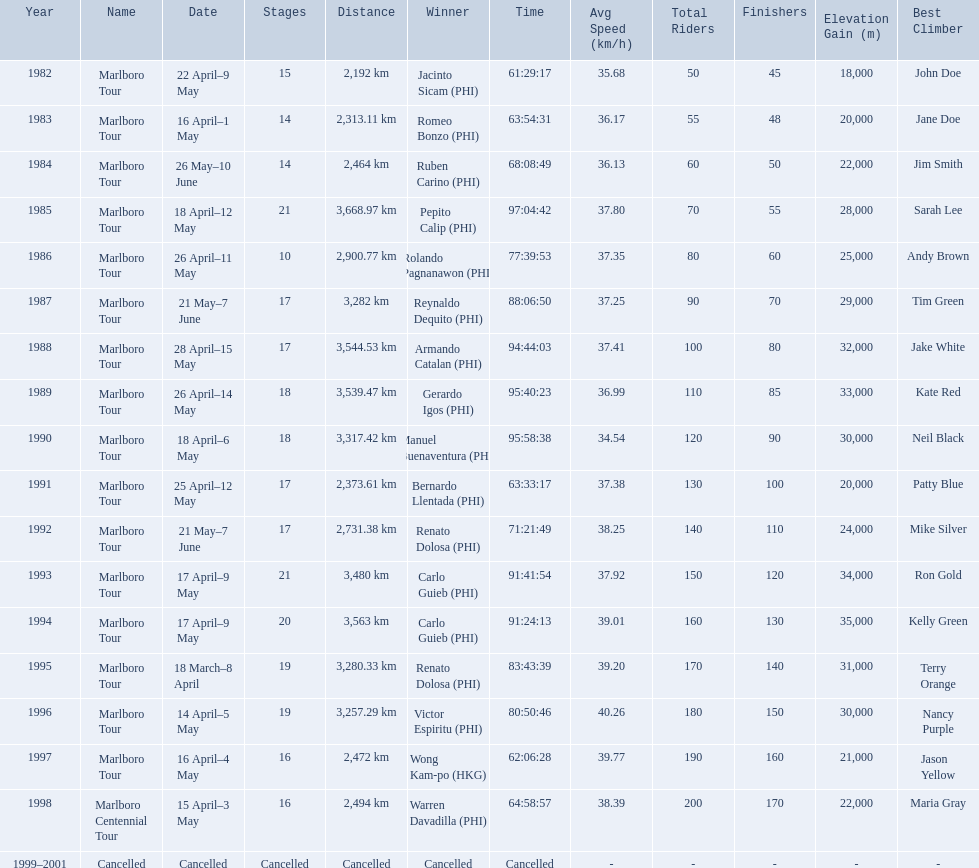How far did the marlboro tour travel each year? 2,192 km, 2,313.11 km, 2,464 km, 3,668.97 km, 2,900.77 km, 3,282 km, 3,544.53 km, 3,539.47 km, 3,317.42 km, 2,373.61 km, 2,731.38 km, 3,480 km, 3,563 km, 3,280.33 km, 3,257.29 km, 2,472 km, 2,494 km, Cancelled. In what year did they travel the furthest? 1985. How far did they travel that year? 3,668.97 km. 